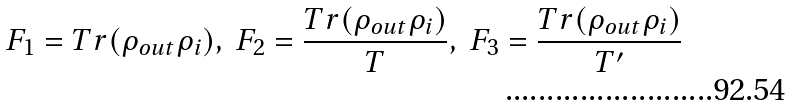<formula> <loc_0><loc_0><loc_500><loc_500>F _ { 1 } = T r ( \rho _ { o u t } \rho _ { i } ) , \ F _ { 2 } = \frac { T r ( \rho _ { o u t } \rho _ { i } ) } { T } , \ F _ { 3 } = \frac { T r ( \rho _ { o u t } \rho _ { i } ) } { T ^ { \prime } }</formula> 